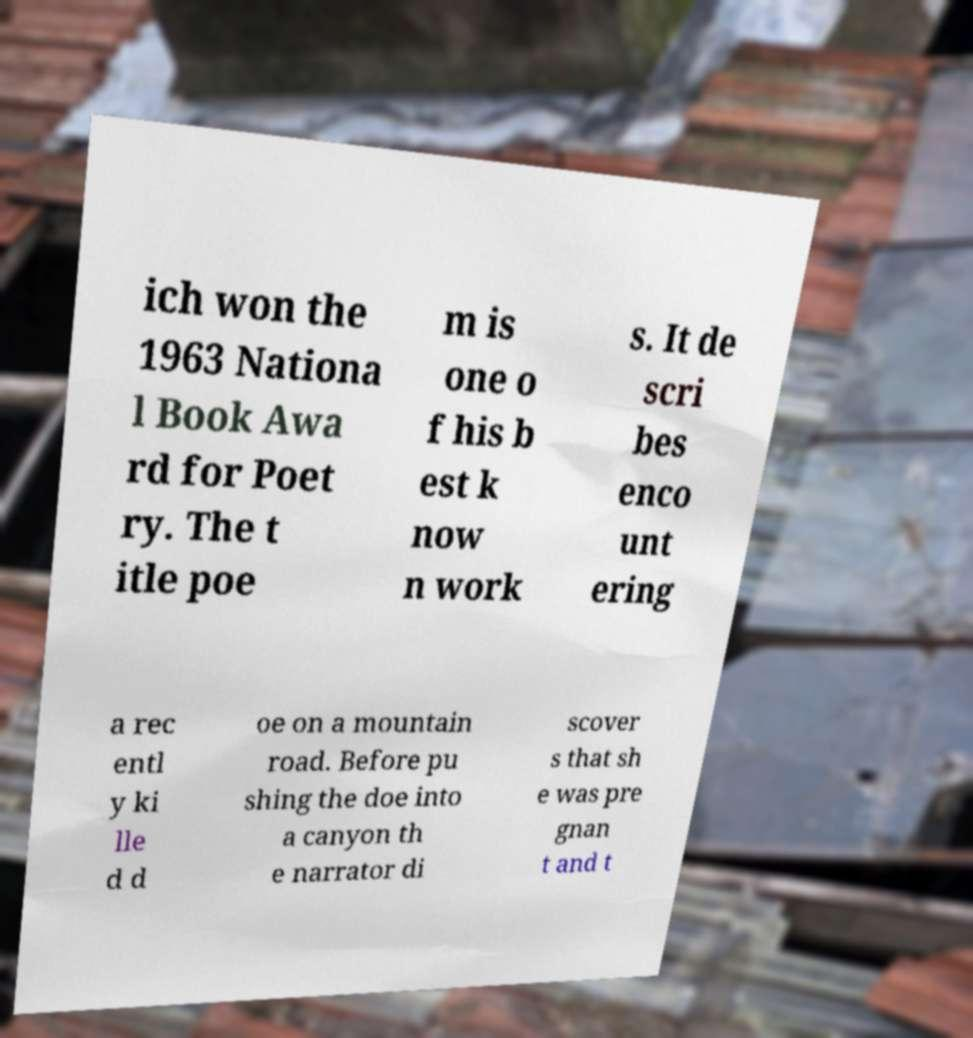Please read and relay the text visible in this image. What does it say? ich won the 1963 Nationa l Book Awa rd for Poet ry. The t itle poe m is one o f his b est k now n work s. It de scri bes enco unt ering a rec entl y ki lle d d oe on a mountain road. Before pu shing the doe into a canyon th e narrator di scover s that sh e was pre gnan t and t 